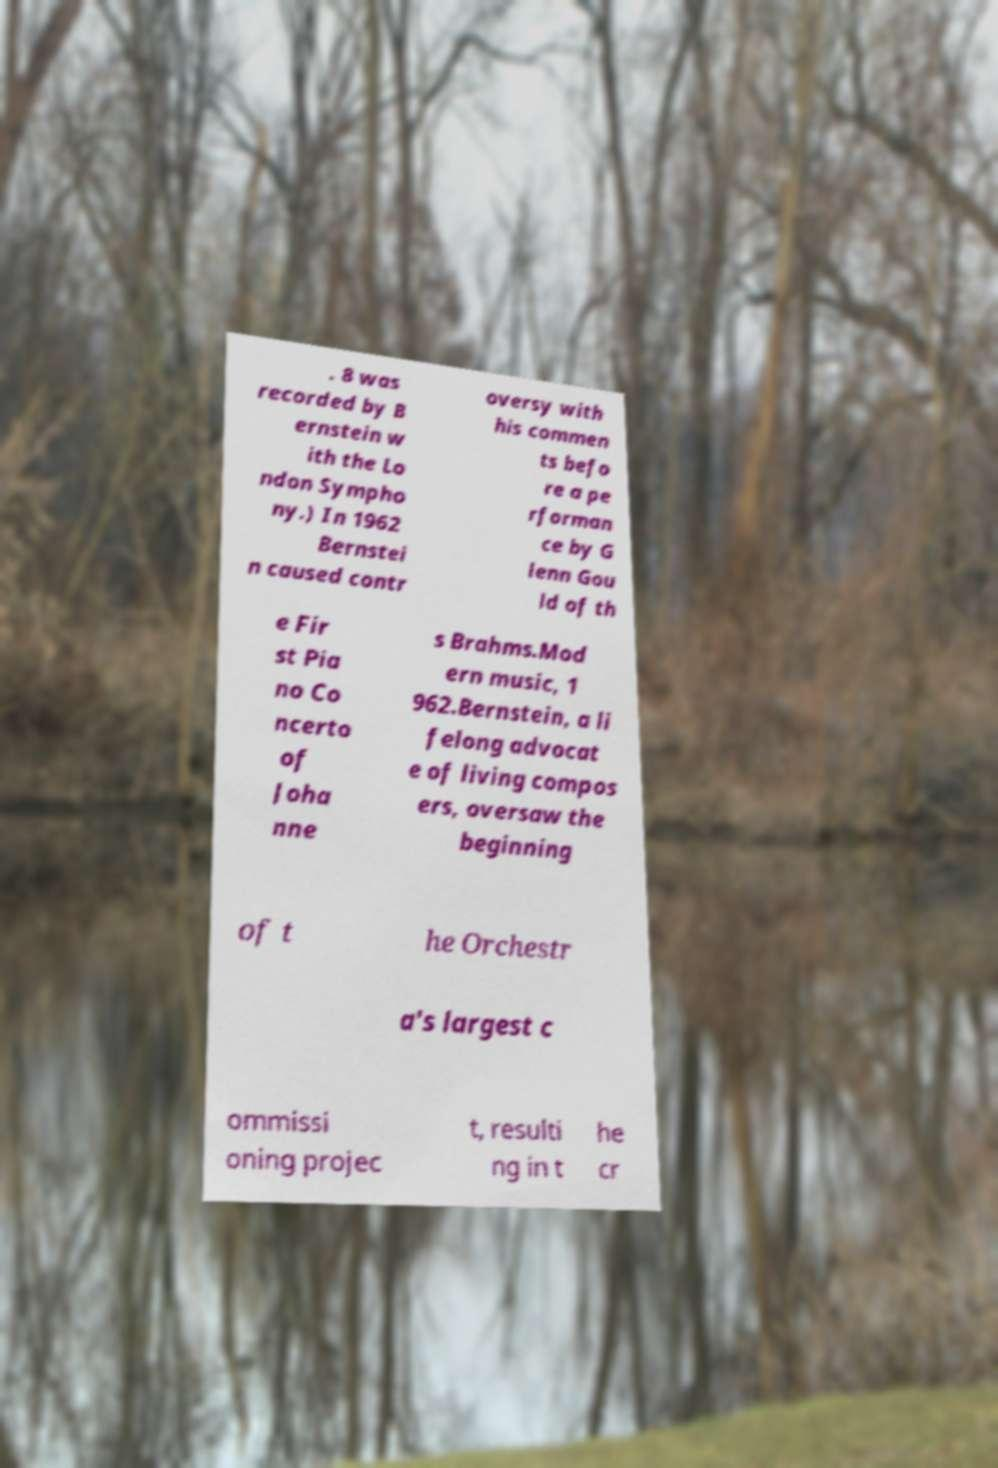Can you read and provide the text displayed in the image?This photo seems to have some interesting text. Can you extract and type it out for me? . 8 was recorded by B ernstein w ith the Lo ndon Sympho ny.) In 1962 Bernstei n caused contr oversy with his commen ts befo re a pe rforman ce by G lenn Gou ld of th e Fir st Pia no Co ncerto of Joha nne s Brahms.Mod ern music, 1 962.Bernstein, a li felong advocat e of living compos ers, oversaw the beginning of t he Orchestr a's largest c ommissi oning projec t, resulti ng in t he cr 